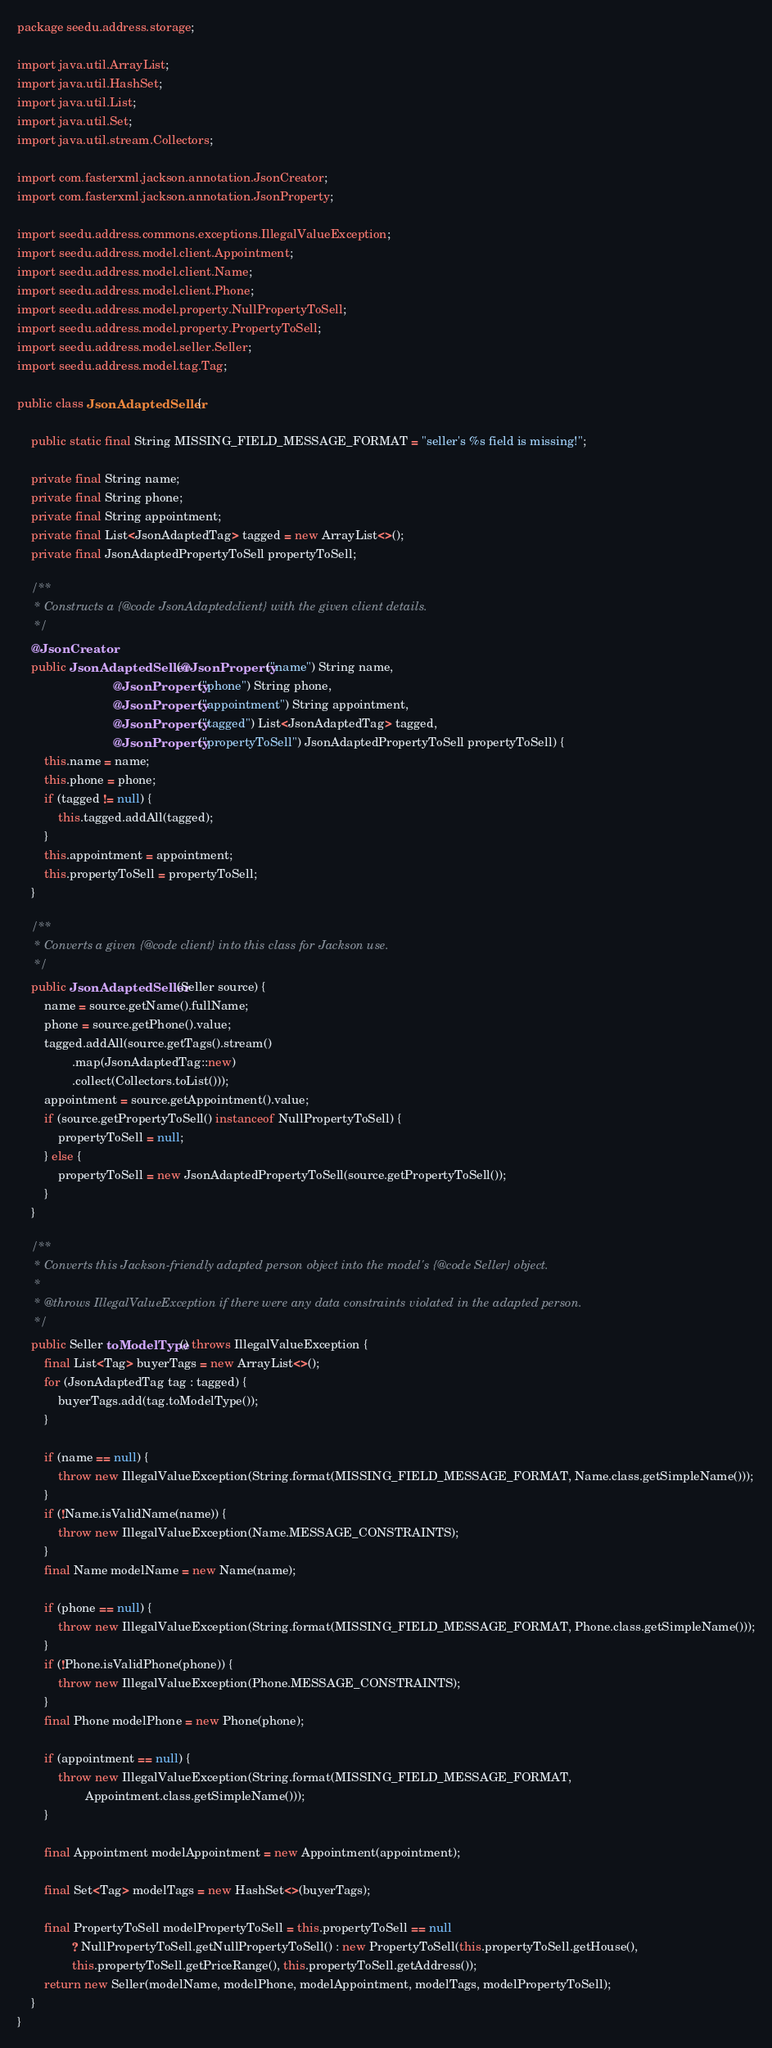Convert code to text. <code><loc_0><loc_0><loc_500><loc_500><_Java_>package seedu.address.storage;

import java.util.ArrayList;
import java.util.HashSet;
import java.util.List;
import java.util.Set;
import java.util.stream.Collectors;

import com.fasterxml.jackson.annotation.JsonCreator;
import com.fasterxml.jackson.annotation.JsonProperty;

import seedu.address.commons.exceptions.IllegalValueException;
import seedu.address.model.client.Appointment;
import seedu.address.model.client.Name;
import seedu.address.model.client.Phone;
import seedu.address.model.property.NullPropertyToSell;
import seedu.address.model.property.PropertyToSell;
import seedu.address.model.seller.Seller;
import seedu.address.model.tag.Tag;

public class JsonAdaptedSeller {

    public static final String MISSING_FIELD_MESSAGE_FORMAT = "seller's %s field is missing!";

    private final String name;
    private final String phone;
    private final String appointment;
    private final List<JsonAdaptedTag> tagged = new ArrayList<>();
    private final JsonAdaptedPropertyToSell propertyToSell;

    /**
     * Constructs a {@code JsonAdaptedclient} with the given client details.
     */
    @JsonCreator
    public JsonAdaptedSeller(@JsonProperty("name") String name,
                            @JsonProperty("phone") String phone,
                            @JsonProperty("appointment") String appointment,
                            @JsonProperty("tagged") List<JsonAdaptedTag> tagged,
                            @JsonProperty("propertyToSell") JsonAdaptedPropertyToSell propertyToSell) {
        this.name = name;
        this.phone = phone;
        if (tagged != null) {
            this.tagged.addAll(tagged);
        }
        this.appointment = appointment;
        this.propertyToSell = propertyToSell;
    }

    /**
     * Converts a given {@code client} into this class for Jackson use.
     */
    public JsonAdaptedSeller(Seller source) {
        name = source.getName().fullName;
        phone = source.getPhone().value;
        tagged.addAll(source.getTags().stream()
                .map(JsonAdaptedTag::new)
                .collect(Collectors.toList()));
        appointment = source.getAppointment().value;
        if (source.getPropertyToSell() instanceof NullPropertyToSell) {
            propertyToSell = null;
        } else {
            propertyToSell = new JsonAdaptedPropertyToSell(source.getPropertyToSell());
        }
    }

    /**
     * Converts this Jackson-friendly adapted person object into the model's {@code Seller} object.
     *
     * @throws IllegalValueException if there were any data constraints violated in the adapted person.
     */
    public Seller toModelType() throws IllegalValueException {
        final List<Tag> buyerTags = new ArrayList<>();
        for (JsonAdaptedTag tag : tagged) {
            buyerTags.add(tag.toModelType());
        }

        if (name == null) {
            throw new IllegalValueException(String.format(MISSING_FIELD_MESSAGE_FORMAT, Name.class.getSimpleName()));
        }
        if (!Name.isValidName(name)) {
            throw new IllegalValueException(Name.MESSAGE_CONSTRAINTS);
        }
        final Name modelName = new Name(name);

        if (phone == null) {
            throw new IllegalValueException(String.format(MISSING_FIELD_MESSAGE_FORMAT, Phone.class.getSimpleName()));
        }
        if (!Phone.isValidPhone(phone)) {
            throw new IllegalValueException(Phone.MESSAGE_CONSTRAINTS);
        }
        final Phone modelPhone = new Phone(phone);

        if (appointment == null) {
            throw new IllegalValueException(String.format(MISSING_FIELD_MESSAGE_FORMAT,
                    Appointment.class.getSimpleName()));
        }

        final Appointment modelAppointment = new Appointment(appointment);

        final Set<Tag> modelTags = new HashSet<>(buyerTags);

        final PropertyToSell modelPropertyToSell = this.propertyToSell == null
                ? NullPropertyToSell.getNullPropertyToSell() : new PropertyToSell(this.propertyToSell.getHouse(),
                this.propertyToSell.getPriceRange(), this.propertyToSell.getAddress());
        return new Seller(modelName, modelPhone, modelAppointment, modelTags, modelPropertyToSell);
    }
}
</code> 